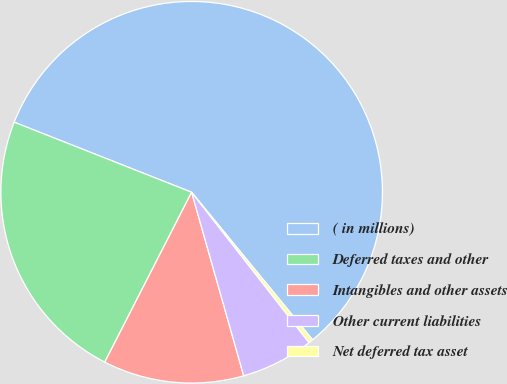Convert chart to OTSL. <chart><loc_0><loc_0><loc_500><loc_500><pie_chart><fcel>( in millions)<fcel>Deferred taxes and other<fcel>Intangibles and other assets<fcel>Other current liabilities<fcel>Net deferred tax asset<nl><fcel>58.08%<fcel>23.46%<fcel>11.92%<fcel>6.15%<fcel>0.38%<nl></chart> 